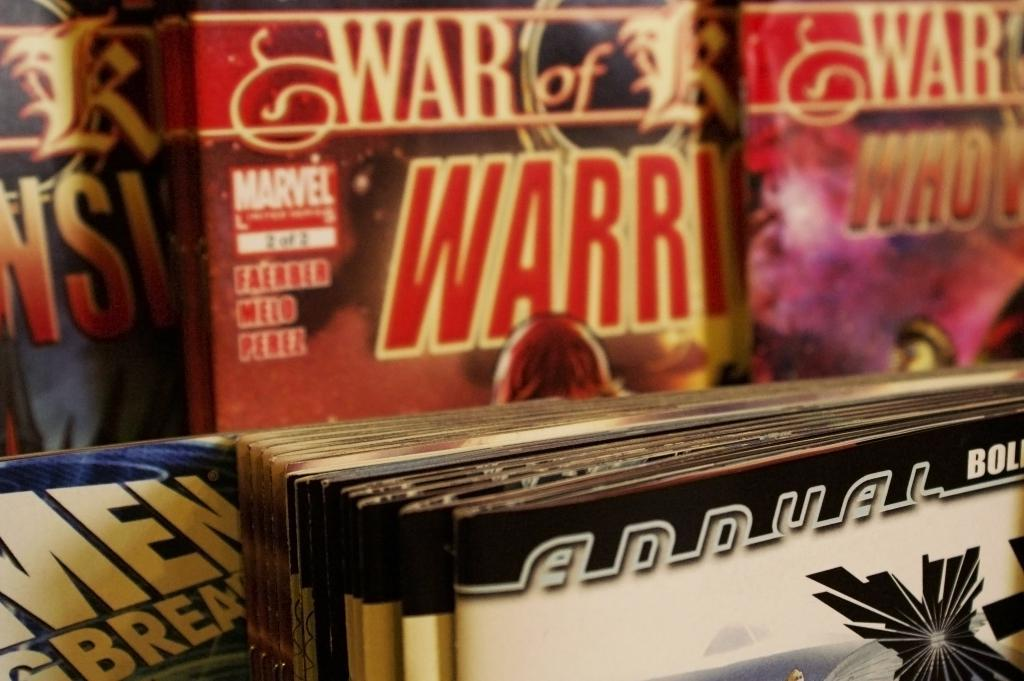Provide a one-sentence caption for the provided image. Stacks of comic books sit on display for the Marvel Comics company. 